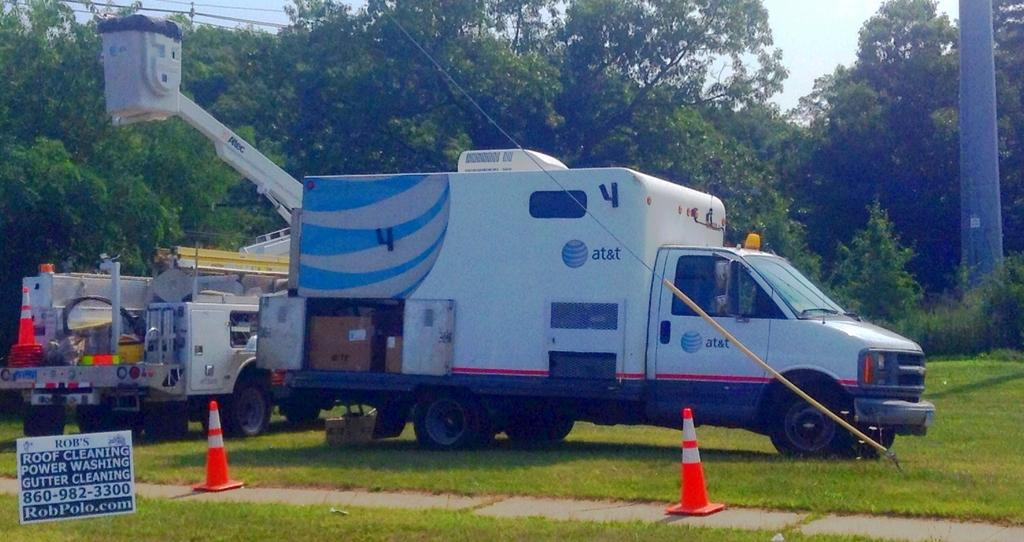<image>
Share a concise interpretation of the image provided. Rob's roof cleaning, power washing, and gutter cleaning on a sign for robpolo.com. 